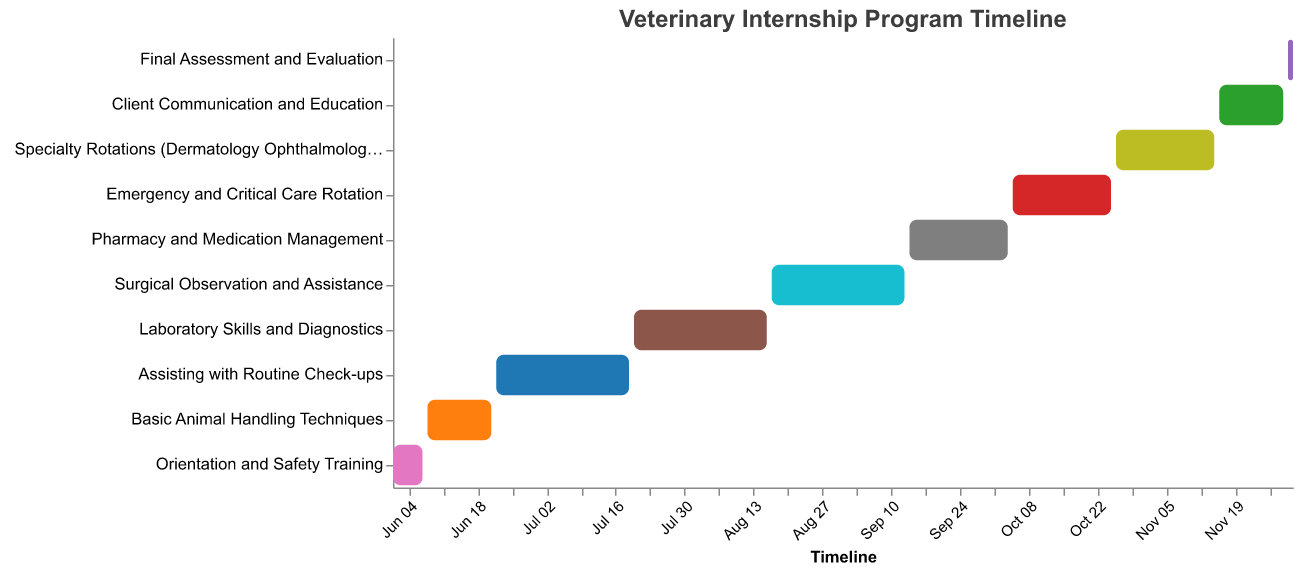How long is the "Laboratory Skills and Diagnostics" task? The "Laboratory Skills and Diagnostics" task starts on July 20, 2023, and ends on August 16, 2023. Calculating the difference between the start and end dates gives 27 days.
Answer: 27 days Which task ends first, "Basic Animal Handling Techniques" or "Orientation and Safety Training"? "Orientation and Safety Training" ends on June 7, 2023, and "Basic Animal Handling Techniques" ends on June 21, 2023. Since June 7 comes before June 21, "Orientation and Safety Training" ends first.
Answer: Orientation and Safety Training What is the duration of the "Final Assessment and Evaluation" task? The "Final Assessment and Evaluation" task starts on November 30, 2023, and ends on December 1, 2023. This task spans just 2 days.
Answer: 2 days How many tasks are in the entire internship program? The Gantt Chart lists a total of 10 tasks for the internship program.
Answer: 10 tasks What is the total duration of the internship program from the start of the first task to the end of the last task? The internship starts with "Orientation and Safety Training" on June 1, 2023, and ends with "Final Assessment and Evaluation" on December 1, 2023. The total duration is from June 1 to December 1, which is 184 days.
Answer: 184 days Which task has the longest duration, and how long is it? "Assisting with Routine Check-ups" starts on June 22, 2023, and ends on July 19, 2023. Calculating the duration, we get 27 days. This equals the duration of the "Laboratory Skills and Diagnostics" task, which also lasts 27 days. Thus, there are two tasks with the longest duration of 27 days.
Answer: Assisting with Routine Check-ups and Laboratory Skills and Diagnostics, 27 days During which month does the "Emergency and Critical Care Rotation" task take place? The "Emergency and Critical Care Rotation" task starts on October 5, 2023, and ends on October 25, 2023. So, it takes place in October.
Answer: October What are the dates for the task immediately following "Surgical Observation and Assistance"? The task immediately following "Surgical Observation and Assistance" is "Pharmacy and Medication Management", which starts on September 14, 2023, and ends on October 4, 2023.
Answer: September 14, 2023 - October 4, 2023 Compare the durations of "Specialty Rotations" and "Client Communication and Education". Which one is longer and by how many days? "Specialty Rotations" runs from October 26, 2023, to November 15, 2023, which is 21 days. "Client Communication and Education" runs from November 16, 2023, to November 29, 2023, which is 14 days. Therefore, "Specialty Rotations" is 7 days longer.
Answer: Specialty Rotations by 7 days 